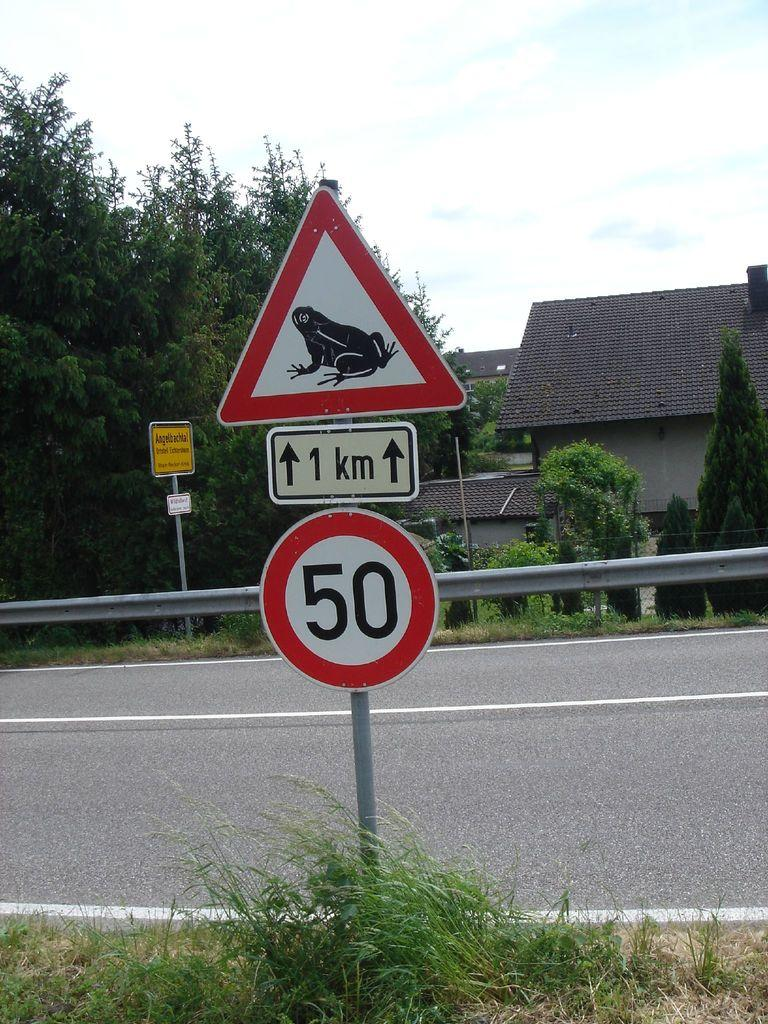<image>
Present a compact description of the photo's key features. a frog on a sign with the number 50 below it 